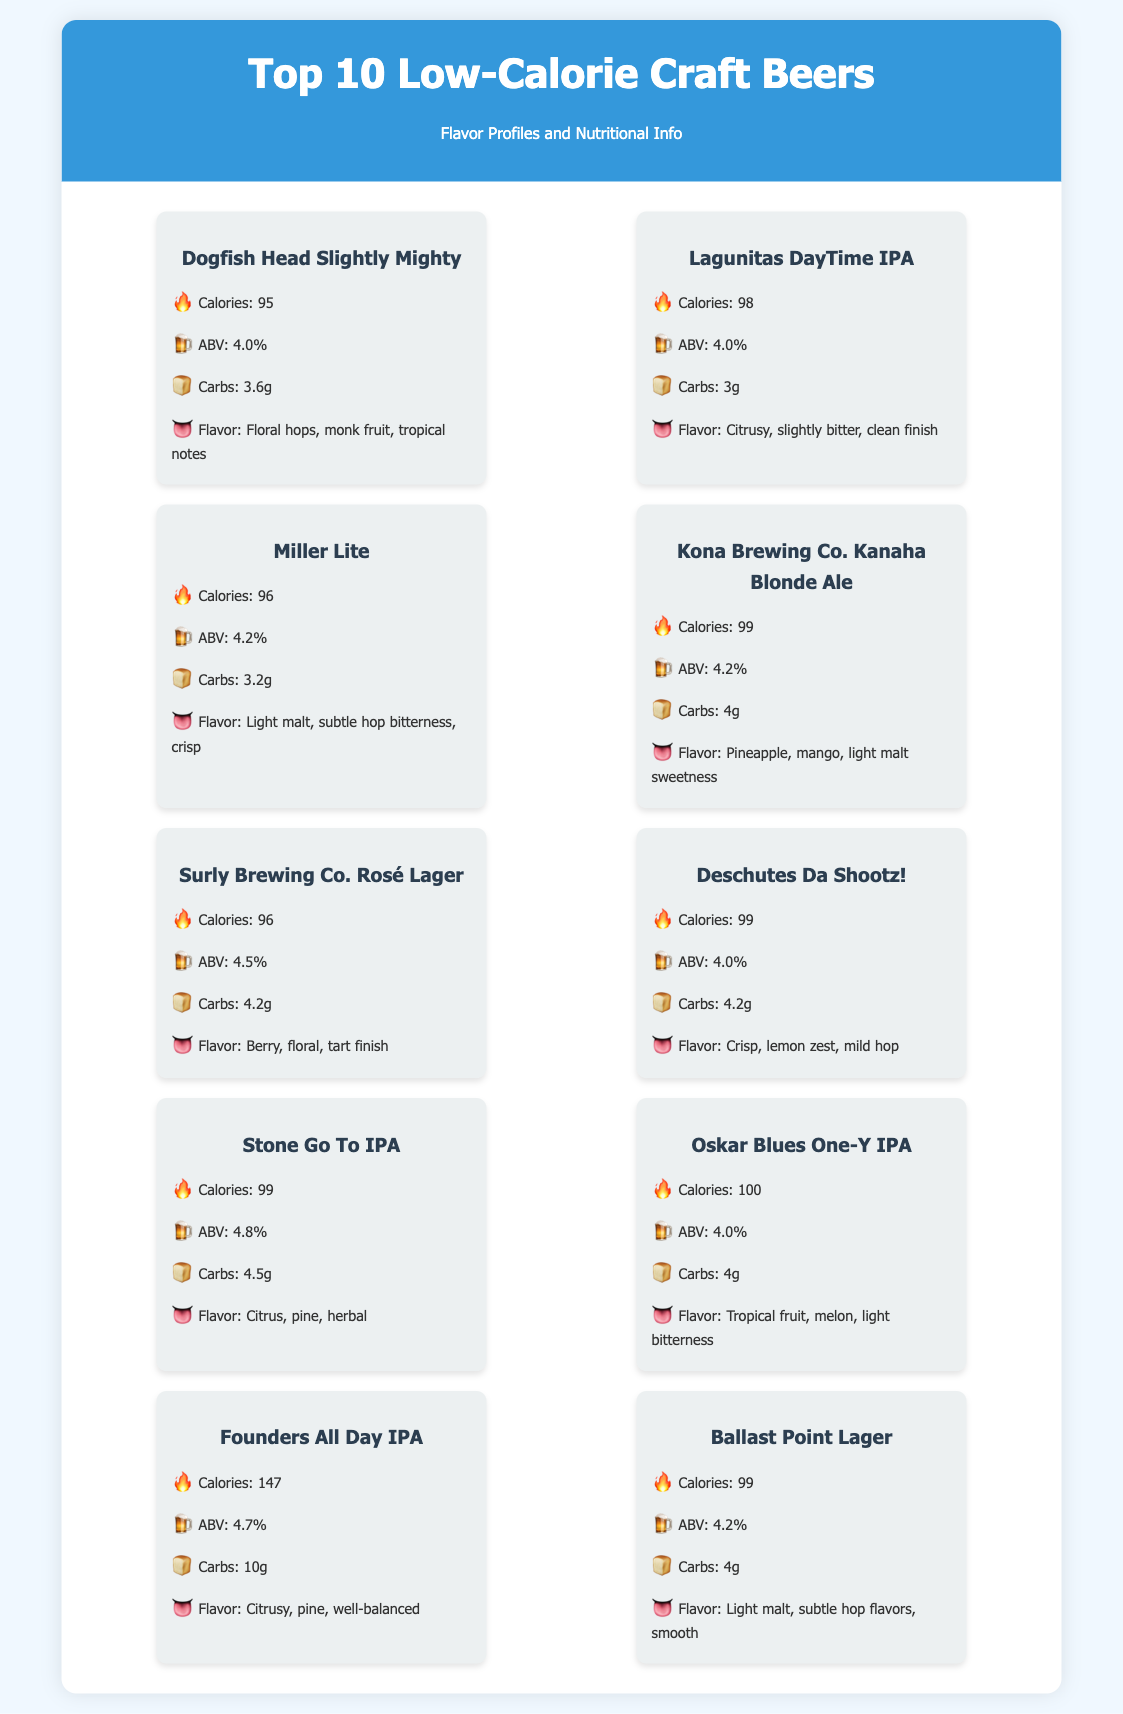What is the calorie count of Dogfish Head Slightly Mighty? The calorie count for Dogfish Head Slightly Mighty is explicitly stated in the document.
Answer: 95 What is the ABV of Lagunitas DayTime IPA? The ABV for Lagunitas DayTime IPA can be found in the nutritional info section of the document.
Answer: 4.0% Which beer has the highest calorie count? The document lists each beer's calorie count, and the maximum is identified through comparison.
Answer: Founders All Day IPA What flavor is associated with Kona Brewing Co. Kanaha Blonde Ale? The flavor notes for Kona Brewing Co. Kanaha Blonde Ale are provided, which allows for direct reference.
Answer: Pineapple, mango, light malt sweetness How many beers listed have an ABV of 4.0%? By counting the ABVs listed for each beer, one can identify those that match the specified value.
Answer: 4 What is the main flavor profile of Miller Lite? The flavor description for Miller Lite is outlined in the document.
Answer: Light malt, subtle hop bitterness, crisp How many grams of carbs are in Surly Brewing Co. Rosé Lager? The document specifies the carb amount for Surly Brewing Co. Rosé Lager, allowing for direct retrieval.
Answer: 4.2g What beer has a flavor profile of citrus, pine, well-balanced? This flavor profile is associated with one of the beers in the document, which can be located within the flavor descriptions.
Answer: Founders All Day IPA Which beer has a calorie count of 100? The calorie count for each beer is listed, making it easy to find the one with this specific count.
Answer: Oskar Blues One-Y IPA 